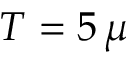Convert formula to latex. <formula><loc_0><loc_0><loc_500><loc_500>T = 5 \, \mu</formula> 